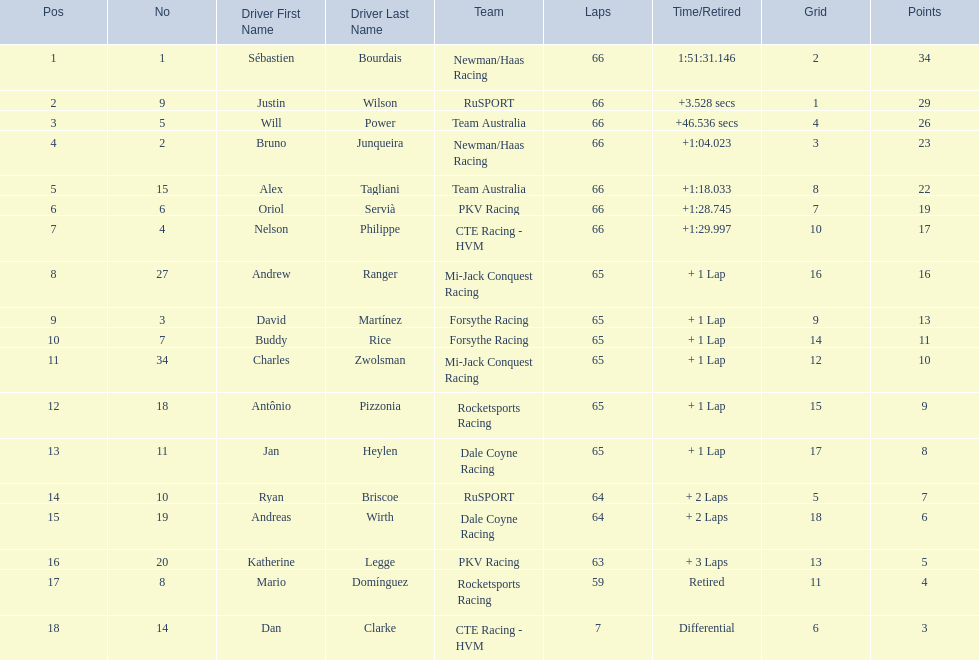Who are the drivers? Sébastien Bourdais, Justin Wilson, Will Power, Bruno Junqueira, Alex Tagliani, Oriol Servià, Nelson Philippe, Andrew Ranger, David Martínez, Buddy Rice, Charles Zwolsman, Antônio Pizzonia, Jan Heylen, Ryan Briscoe, Andreas Wirth, Katherine Legge, Mario Domínguez, Dan Clarke. What are their numbers? 1, 9, 5, 2, 15, 6, 4, 27, 3, 7, 34, 18, 11, 10, 19, 20, 8, 14. What are their positions? 1, 2, 3, 4, 5, 6, 7, 8, 9, 10, 11, 12, 13, 14, 15, 16, 17, 18. Which driver has the same number and position? Sébastien Bourdais. 